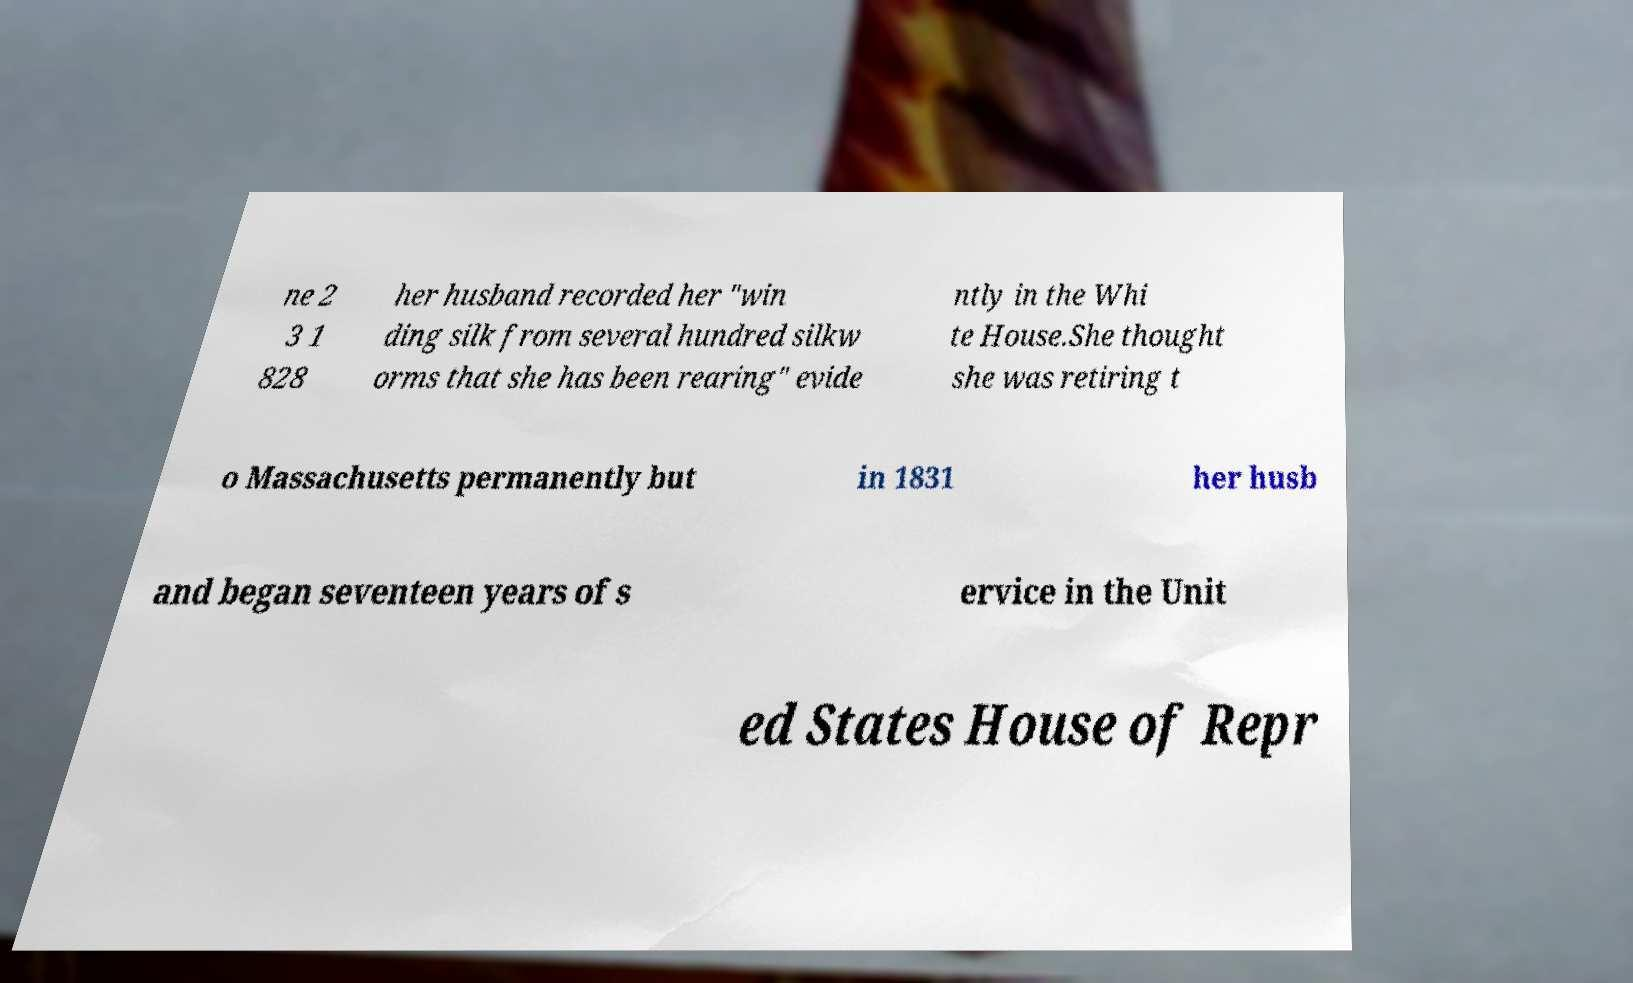Please identify and transcribe the text found in this image. ne 2 3 1 828 her husband recorded her "win ding silk from several hundred silkw orms that she has been rearing" evide ntly in the Whi te House.She thought she was retiring t o Massachusetts permanently but in 1831 her husb and began seventeen years of s ervice in the Unit ed States House of Repr 